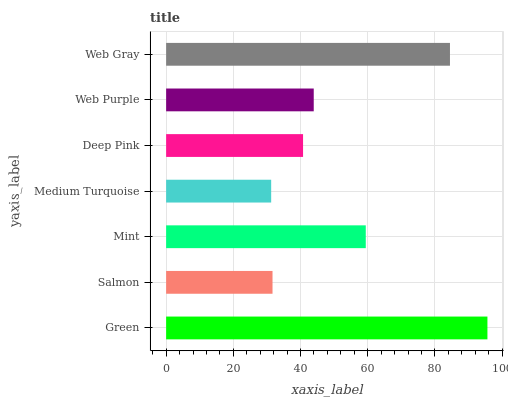Is Medium Turquoise the minimum?
Answer yes or no. Yes. Is Green the maximum?
Answer yes or no. Yes. Is Salmon the minimum?
Answer yes or no. No. Is Salmon the maximum?
Answer yes or no. No. Is Green greater than Salmon?
Answer yes or no. Yes. Is Salmon less than Green?
Answer yes or no. Yes. Is Salmon greater than Green?
Answer yes or no. No. Is Green less than Salmon?
Answer yes or no. No. Is Web Purple the high median?
Answer yes or no. Yes. Is Web Purple the low median?
Answer yes or no. Yes. Is Medium Turquoise the high median?
Answer yes or no. No. Is Medium Turquoise the low median?
Answer yes or no. No. 